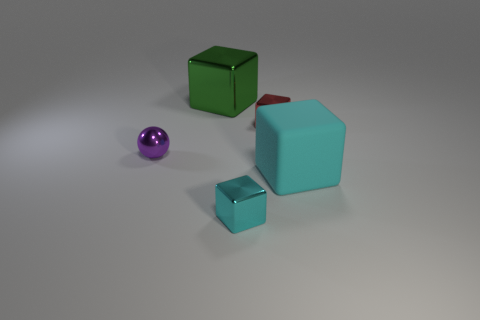What number of things are both left of the large matte cube and right of the purple metallic sphere?
Offer a terse response. 3. There is a green cube; does it have the same size as the metallic object that is in front of the purple shiny object?
Your response must be concise. No. There is a small metal block that is left of the small block that is behind the cyan shiny thing; is there a cyan rubber object that is in front of it?
Offer a very short reply. No. What is the block behind the small object that is behind the small purple ball made of?
Provide a short and direct response. Metal. What is the block that is both in front of the large green thing and behind the large rubber cube made of?
Your answer should be compact. Metal. Are there any small cyan things that have the same shape as the tiny purple metallic object?
Make the answer very short. No. There is a small metal block in front of the small purple thing; are there any small cyan blocks right of it?
Provide a short and direct response. No. How many tiny cyan cubes are the same material as the small ball?
Give a very brief answer. 1. Is there a blue block?
Make the answer very short. No. What number of small shiny things are the same color as the metallic ball?
Your answer should be compact. 0. 